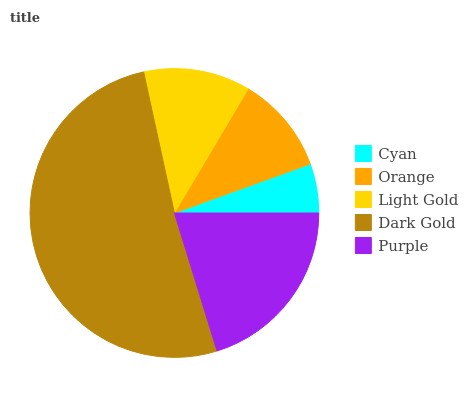Is Cyan the minimum?
Answer yes or no. Yes. Is Dark Gold the maximum?
Answer yes or no. Yes. Is Orange the minimum?
Answer yes or no. No. Is Orange the maximum?
Answer yes or no. No. Is Orange greater than Cyan?
Answer yes or no. Yes. Is Cyan less than Orange?
Answer yes or no. Yes. Is Cyan greater than Orange?
Answer yes or no. No. Is Orange less than Cyan?
Answer yes or no. No. Is Light Gold the high median?
Answer yes or no. Yes. Is Light Gold the low median?
Answer yes or no. Yes. Is Cyan the high median?
Answer yes or no. No. Is Cyan the low median?
Answer yes or no. No. 